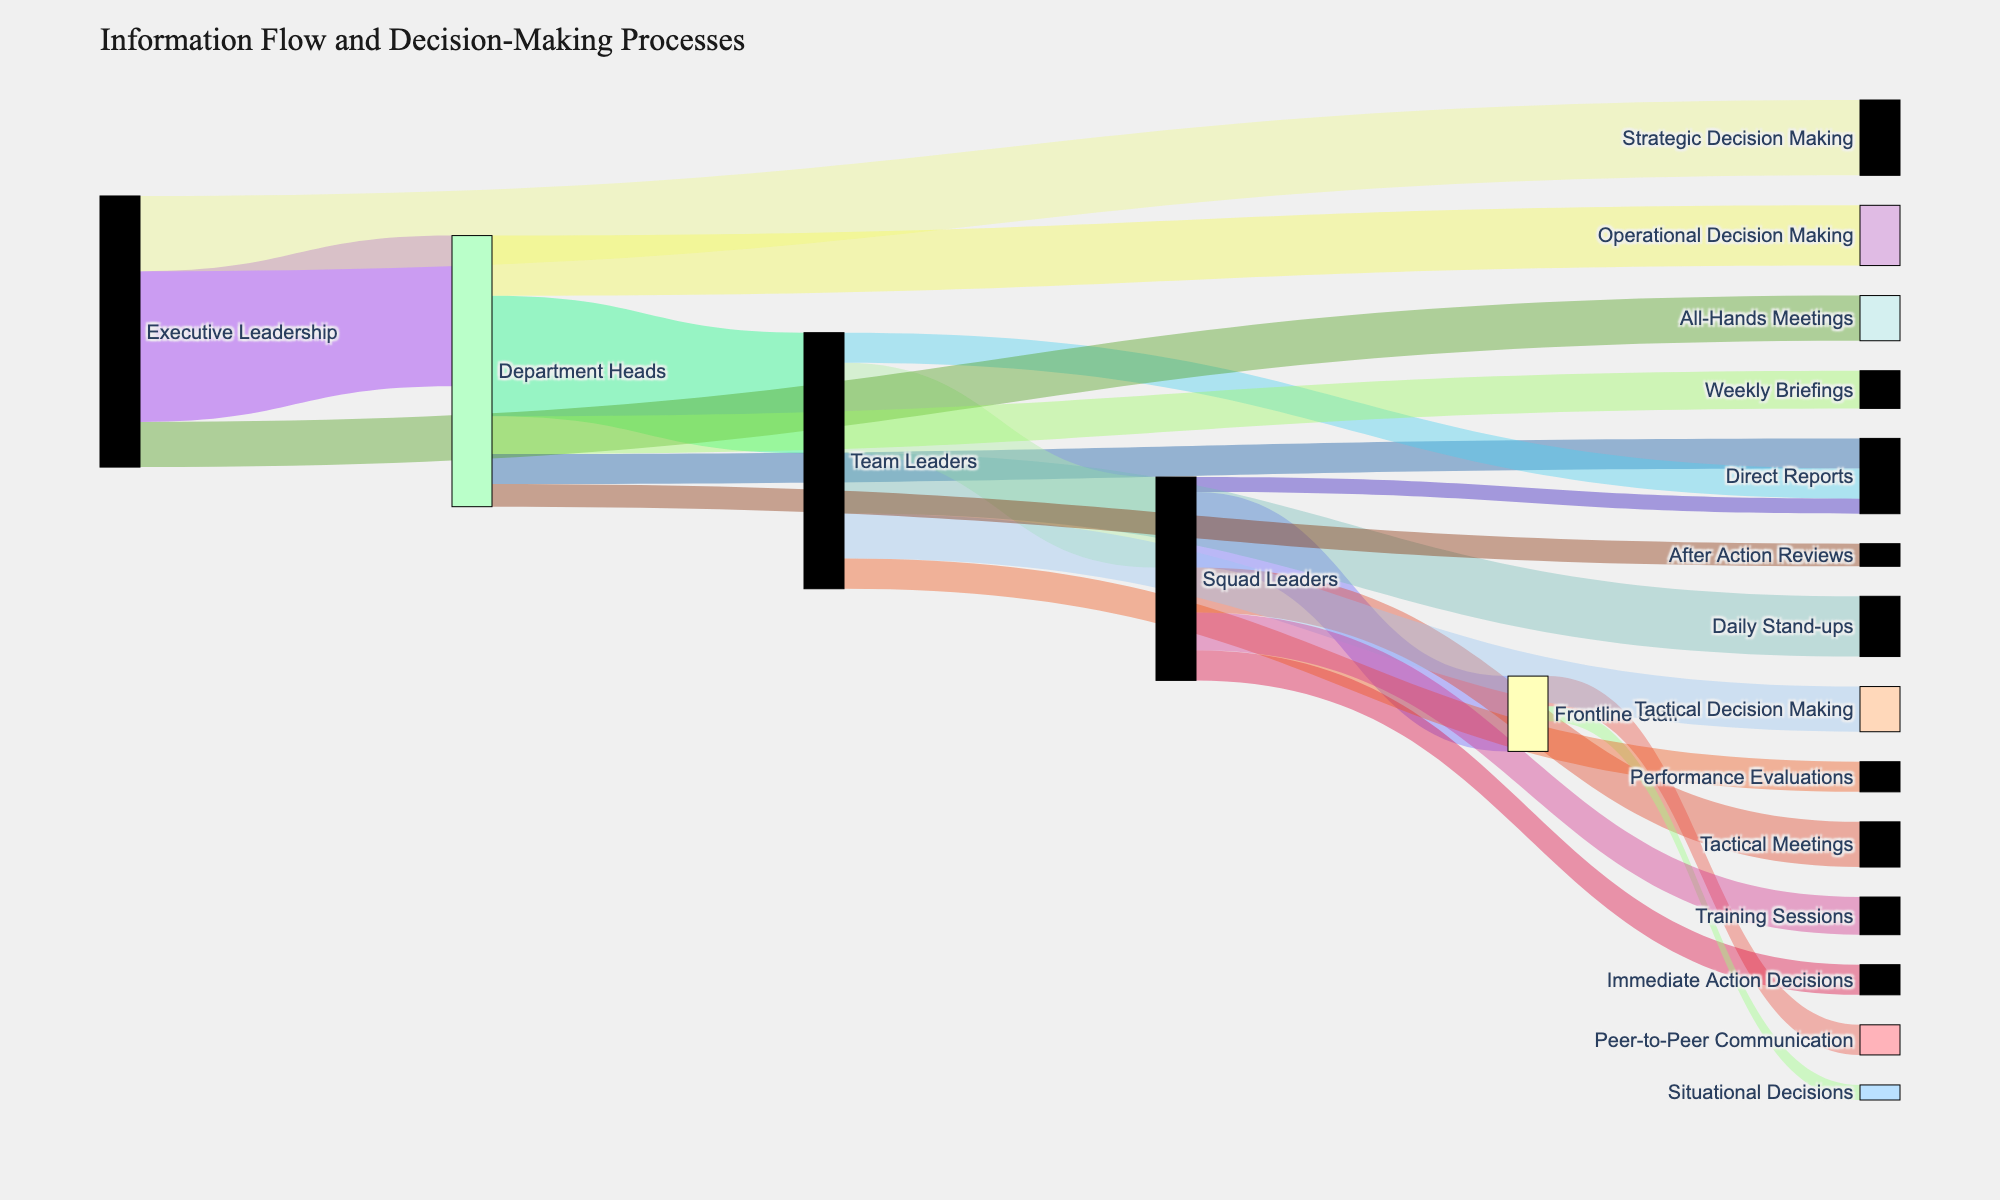How many categories are there for "Executive Leadership" in terms of information flow? The "Executive Leadership" node contains three outgoing links labeled "Department Heads," "All-Hands Meetings," and "Strategic Decision Making." Count these links to find the number of categories.
Answer: 3 What is the value of information flow from "Department Heads" to "Team Leaders"? The connection between "Department Heads" and "Team Leaders" shows a value of 80.
Answer: 80 Which group handles the most strategic decision-making responsibilities? The link showing "Strategic Decision Making" originates from "Executive Leadership" with a value of 50. No other group has a link with "Strategic Decision Making" and a higher value.
Answer: Executive Leadership What is the total value for decision-making processes at the "Team Leaders" level? "Team Leaders" have one link labeled "Tactical Decision Making" with a value of 30.
Answer: 30 Which group has the highest cumulative information flow including both decision-making and communication processes? Sum the values of all outgoing links for each group:  
"Executive Leadership": 100 + 30 + 50 = 180  
"Department Heads": 80 + 20 + 25 + 40 + 15 = 180  
"Team Leaders": 60 + 20 + 40 + 30 + 20 = 170  
"Squad Leaders": 50 + 10 + 30 + 20 + 25 = 135  
Hence, both "Executive Leadership" and "Department Heads" have the highest cumulative value.
Answer: Executive Leadership Compare the value of "Immediate Action Decisions" to "Operational Decision Making." Which is higher? The value for "Immediate Action Decisions" is 20, while "Operational Decision Making" has a value of 40. Thus, "Operational Decision Making" is higher.
Answer: Operational Decision Making What is the value difference between "Weekly Briefings" and "After Action Reviews"? "Weekly Briefings" has a value of 25, and "After Action Reviews" has a value of 15. Subtract the smaller value from the larger: 25 - 15 = 10.
Answer: 10 Which subgroup has the most direct reports? Summarize the direct report values linked to each subgroup:  
"Department Heads" to "Direct Reports": 20  
"Team Leaders" to "Direct Reports": 20  
"Squad Leaders" to "Direct Reports": 10  
Both "Department Heads" and "Team Leaders" have the highest number of direct reports with a value of 20 each.
Answer: Department Heads 